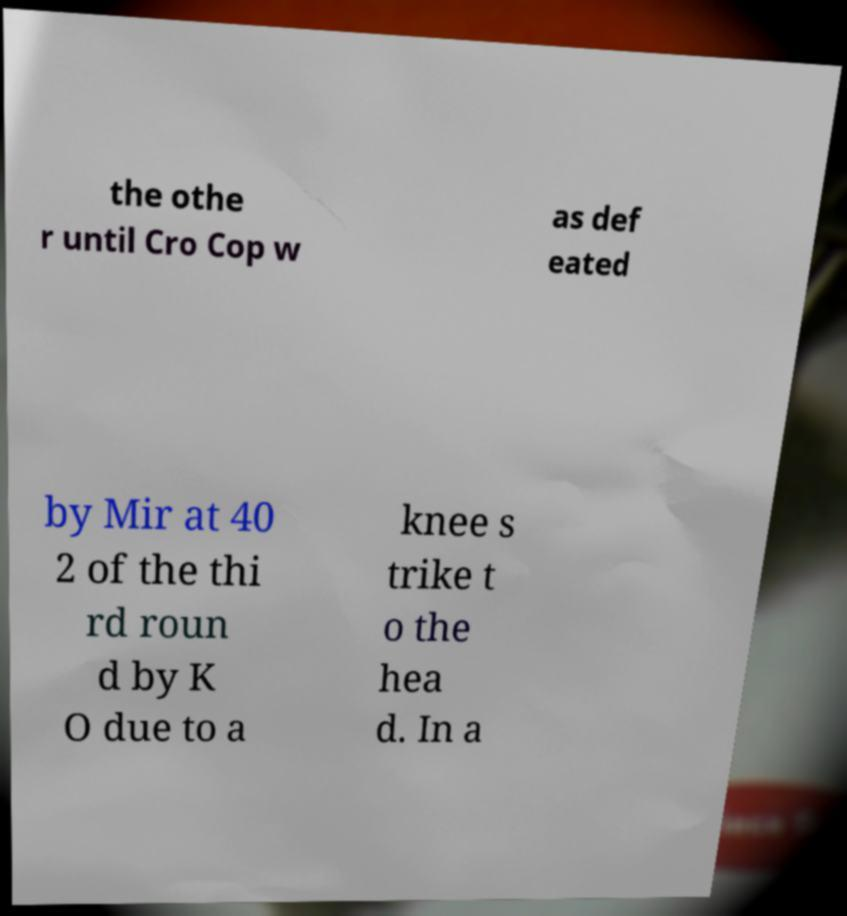For documentation purposes, I need the text within this image transcribed. Could you provide that? the othe r until Cro Cop w as def eated by Mir at 40 2 of the thi rd roun d by K O due to a knee s trike t o the hea d. In a 